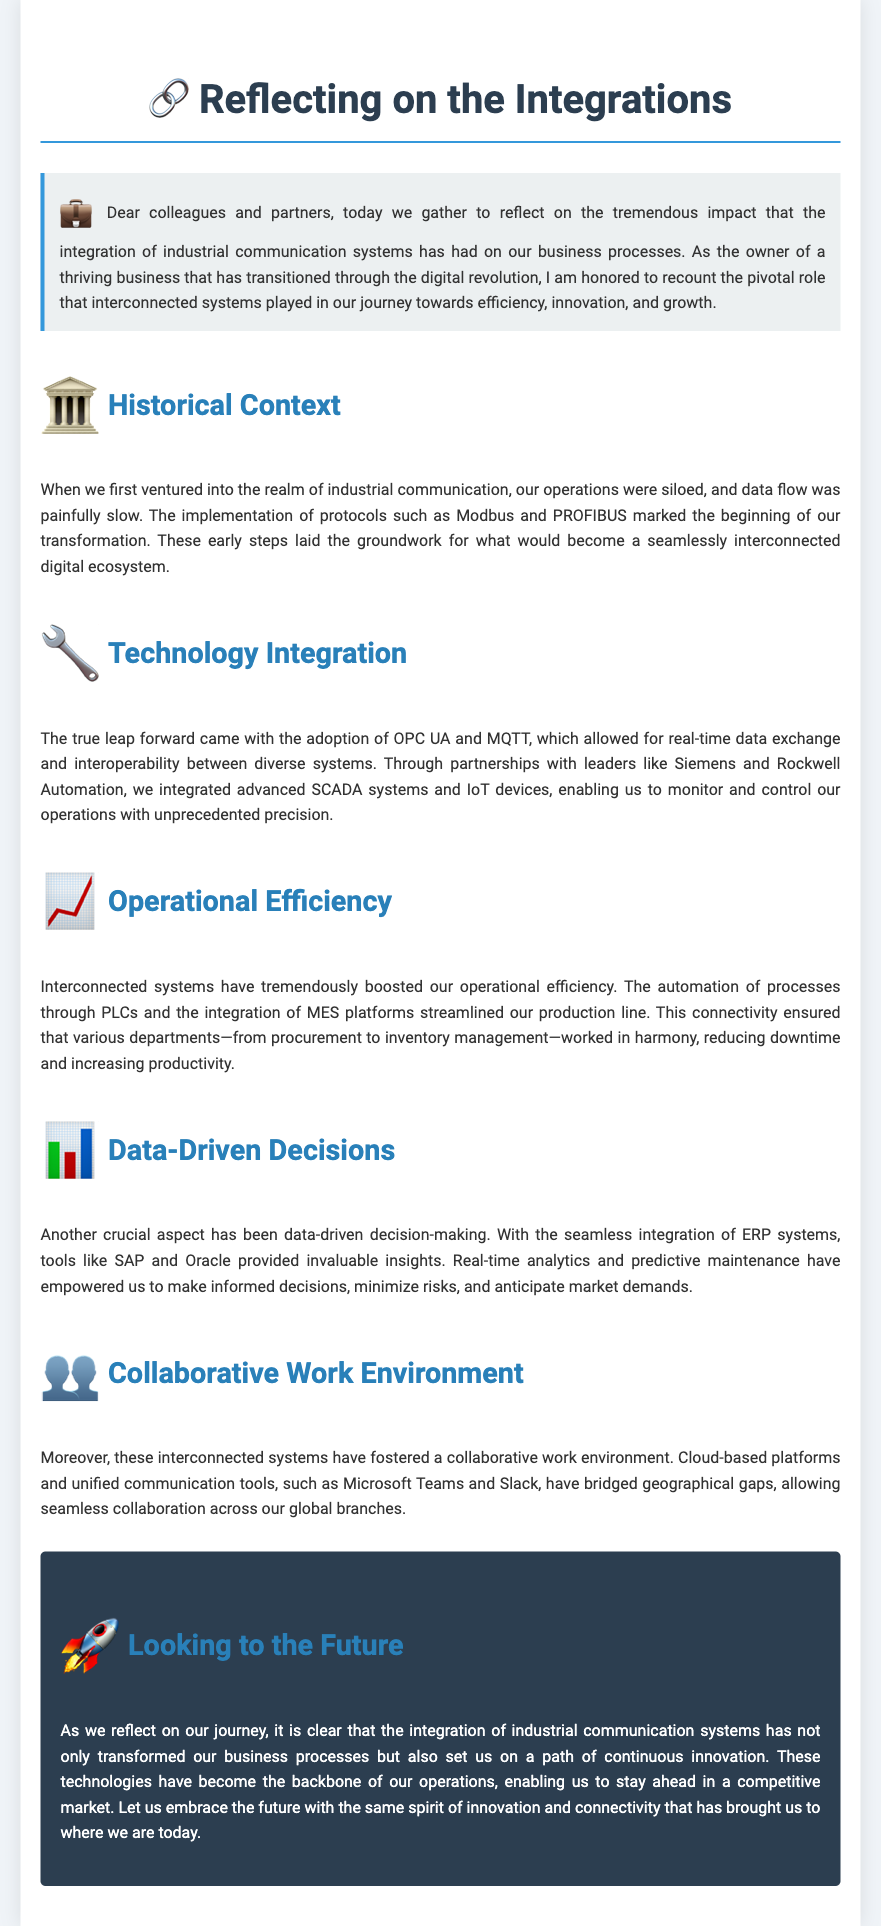What are the two protocols mentioned in the historical context? The document mentions Modbus and PROFIBUS as the early protocols implemented during the historical transition of the business.
Answer: Modbus and PROFIBUS Which advanced systems were integrated through partnerships? The eulogy refers to the integration of advanced SCADA systems and IoT devices through partnerships with Siemens and Rockwell Automation.
Answer: SCADA systems and IoT devices What aspect of decision-making has been emphasized in the document? Data-driven decision-making has been highlighted as a crucial aspect resulting from the integration of ERP systems like SAP and Oracle.
Answer: Data-driven decision-making What technology fosters a collaborative work environment? The document states that cloud-based platforms and unified communication tools like Microsoft Teams and Slack have fostered a collaborative work environment.
Answer: Microsoft Teams and Slack What has been the effect of interconnected systems on productivity? Interconnected systems have reduced downtime and increased productivity across various departments, according to the document.
Answer: Reduced downtime and increased productivity What future outlook does the document suggest for the business? The eulogy expresses an outlook of continuous innovation and connectivity as the future path for the business.
Answer: Continuous innovation and connectivity 